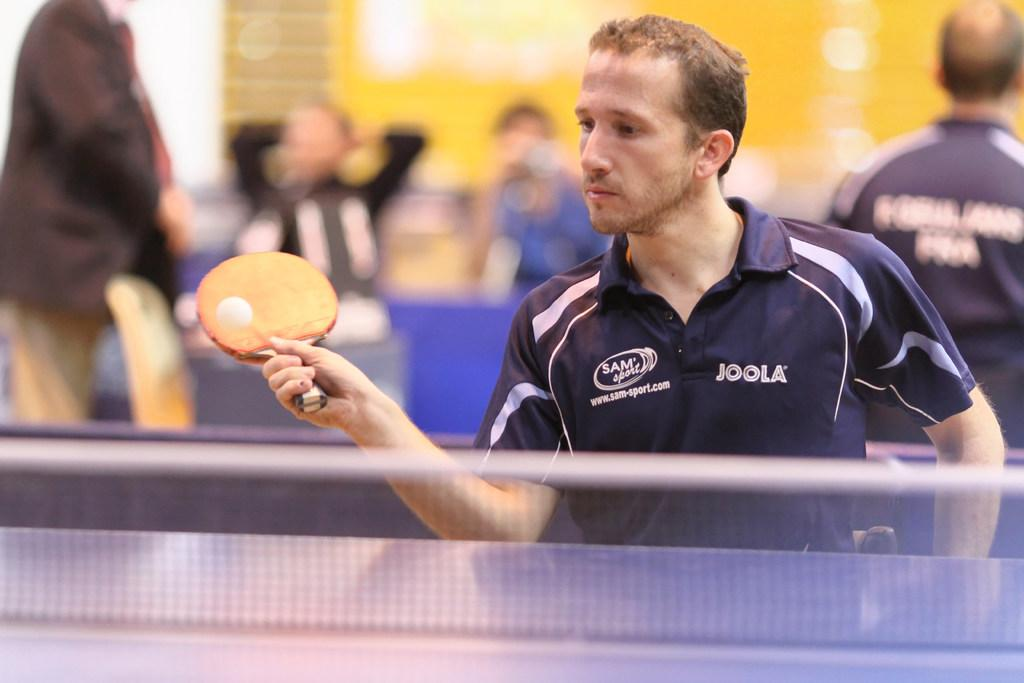<image>
Relay a brief, clear account of the picture shown. A man wearing a JOOLA shirt is playing ping pong. 